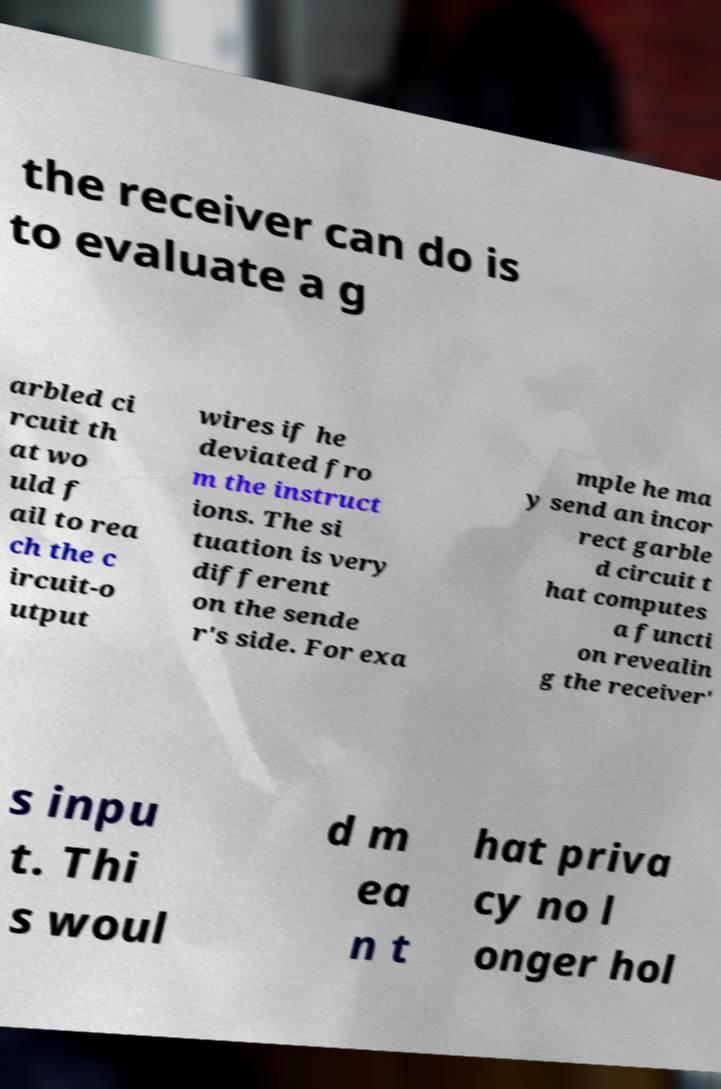What messages or text are displayed in this image? I need them in a readable, typed format. the receiver can do is to evaluate a g arbled ci rcuit th at wo uld f ail to rea ch the c ircuit-o utput wires if he deviated fro m the instruct ions. The si tuation is very different on the sende r's side. For exa mple he ma y send an incor rect garble d circuit t hat computes a functi on revealin g the receiver' s inpu t. Thi s woul d m ea n t hat priva cy no l onger hol 